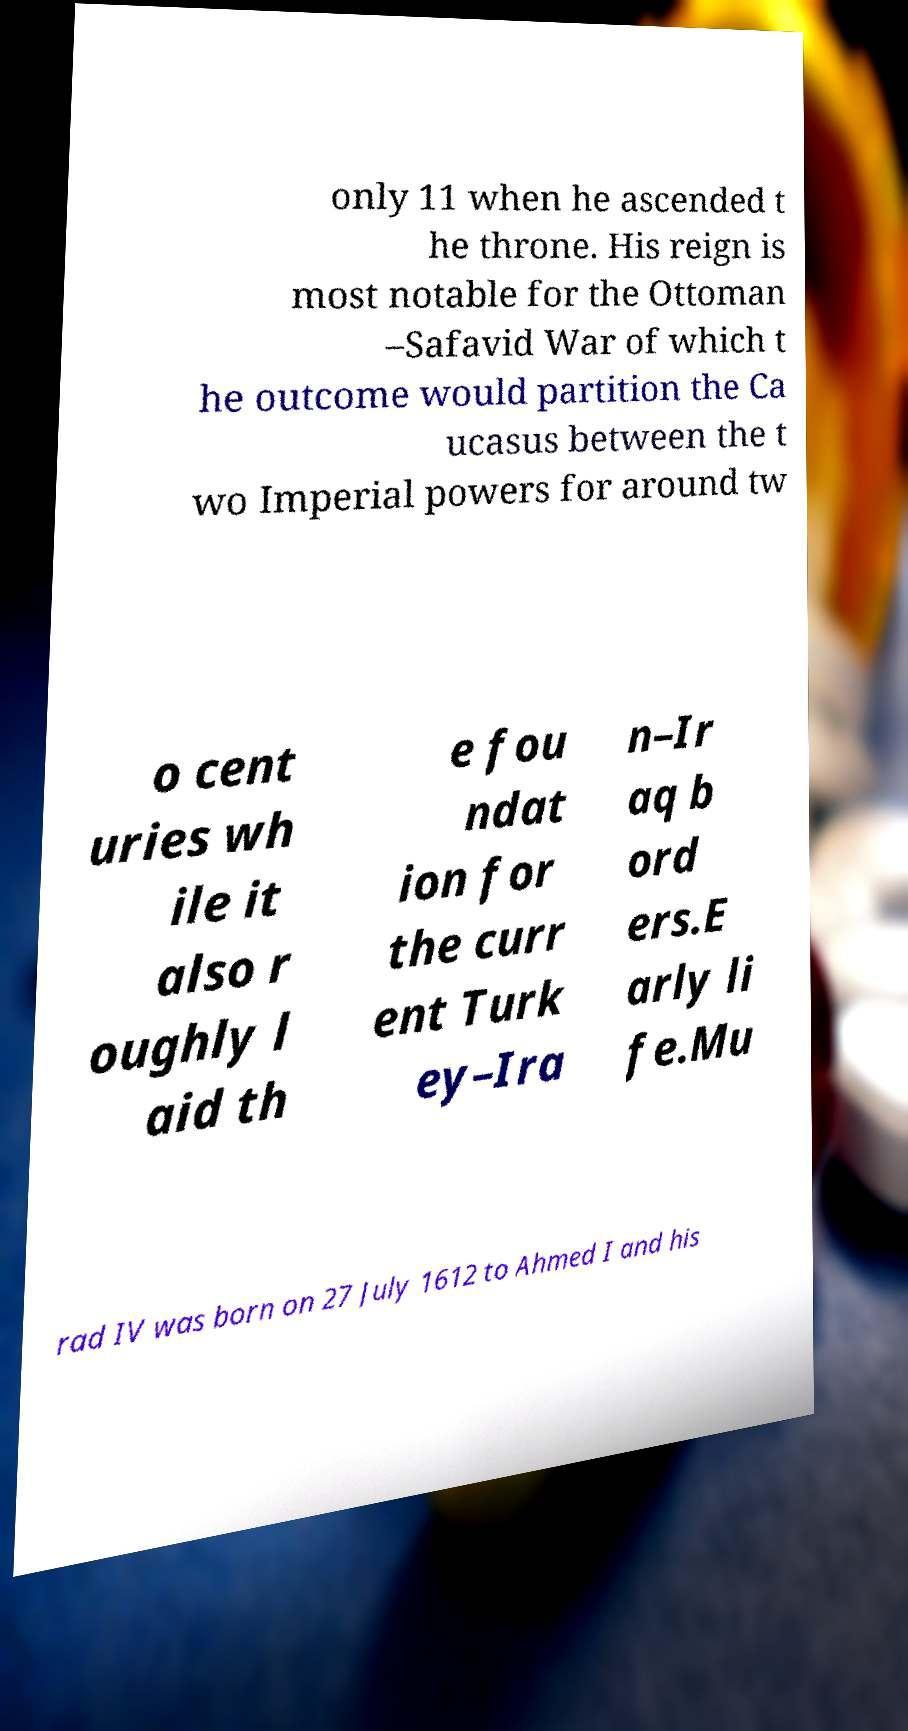Can you read and provide the text displayed in the image?This photo seems to have some interesting text. Can you extract and type it out for me? only 11 when he ascended t he throne. His reign is most notable for the Ottoman –Safavid War of which t he outcome would partition the Ca ucasus between the t wo Imperial powers for around tw o cent uries wh ile it also r oughly l aid th e fou ndat ion for the curr ent Turk ey–Ira n–Ir aq b ord ers.E arly li fe.Mu rad IV was born on 27 July 1612 to Ahmed I and his 